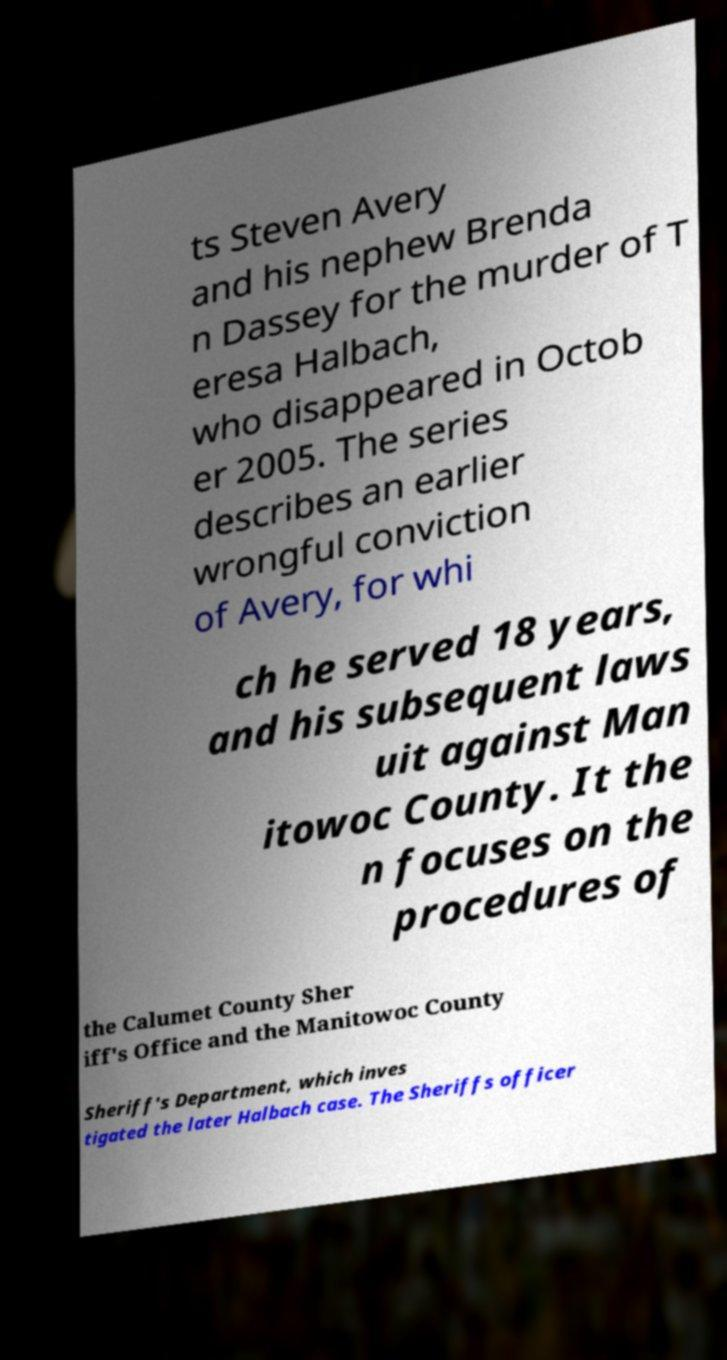I need the written content from this picture converted into text. Can you do that? ts Steven Avery and his nephew Brenda n Dassey for the murder of T eresa Halbach, who disappeared in Octob er 2005. The series describes an earlier wrongful conviction of Avery, for whi ch he served 18 years, and his subsequent laws uit against Man itowoc County. It the n focuses on the procedures of the Calumet County Sher iff's Office and the Manitowoc County Sheriff's Department, which inves tigated the later Halbach case. The Sheriffs officer 